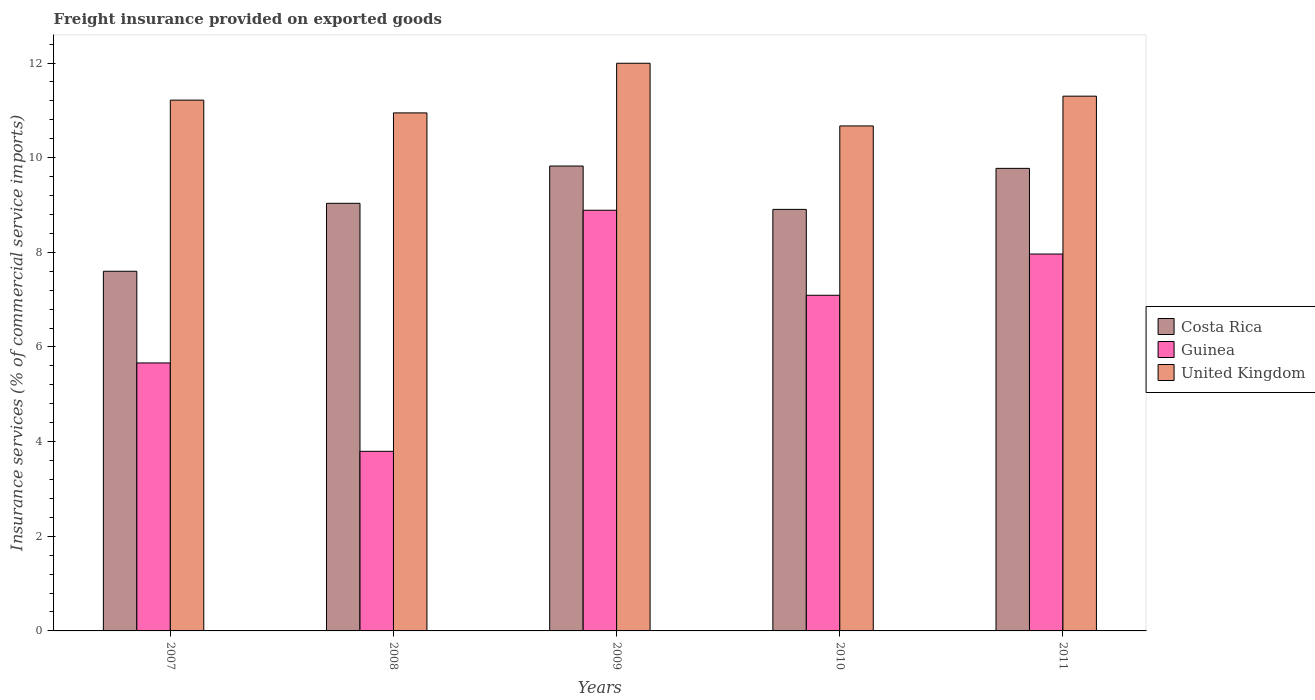How many different coloured bars are there?
Keep it short and to the point. 3. How many groups of bars are there?
Give a very brief answer. 5. In how many cases, is the number of bars for a given year not equal to the number of legend labels?
Your answer should be compact. 0. What is the freight insurance provided on exported goods in Guinea in 2009?
Keep it short and to the point. 8.89. Across all years, what is the maximum freight insurance provided on exported goods in Costa Rica?
Your response must be concise. 9.82. Across all years, what is the minimum freight insurance provided on exported goods in United Kingdom?
Your answer should be very brief. 10.67. In which year was the freight insurance provided on exported goods in Costa Rica maximum?
Offer a very short reply. 2009. In which year was the freight insurance provided on exported goods in United Kingdom minimum?
Offer a very short reply. 2010. What is the total freight insurance provided on exported goods in United Kingdom in the graph?
Provide a short and direct response. 56.13. What is the difference between the freight insurance provided on exported goods in Guinea in 2008 and that in 2010?
Provide a short and direct response. -3.3. What is the difference between the freight insurance provided on exported goods in Costa Rica in 2007 and the freight insurance provided on exported goods in Guinea in 2008?
Your response must be concise. 3.8. What is the average freight insurance provided on exported goods in Costa Rica per year?
Make the answer very short. 9.03. In the year 2008, what is the difference between the freight insurance provided on exported goods in Guinea and freight insurance provided on exported goods in United Kingdom?
Provide a short and direct response. -7.15. What is the ratio of the freight insurance provided on exported goods in Costa Rica in 2007 to that in 2008?
Keep it short and to the point. 0.84. What is the difference between the highest and the second highest freight insurance provided on exported goods in Guinea?
Provide a short and direct response. 0.92. What is the difference between the highest and the lowest freight insurance provided on exported goods in Guinea?
Your response must be concise. 5.09. In how many years, is the freight insurance provided on exported goods in United Kingdom greater than the average freight insurance provided on exported goods in United Kingdom taken over all years?
Make the answer very short. 2. What does the 1st bar from the left in 2008 represents?
Ensure brevity in your answer.  Costa Rica. What does the 2nd bar from the right in 2009 represents?
Keep it short and to the point. Guinea. Is it the case that in every year, the sum of the freight insurance provided on exported goods in Costa Rica and freight insurance provided on exported goods in United Kingdom is greater than the freight insurance provided on exported goods in Guinea?
Offer a very short reply. Yes. How many bars are there?
Offer a very short reply. 15. Are all the bars in the graph horizontal?
Make the answer very short. No. How many years are there in the graph?
Provide a short and direct response. 5. Does the graph contain grids?
Provide a succinct answer. No. Where does the legend appear in the graph?
Keep it short and to the point. Center right. How many legend labels are there?
Ensure brevity in your answer.  3. What is the title of the graph?
Give a very brief answer. Freight insurance provided on exported goods. What is the label or title of the Y-axis?
Your response must be concise. Insurance services (% of commercial service imports). What is the Insurance services (% of commercial service imports) in Costa Rica in 2007?
Provide a succinct answer. 7.6. What is the Insurance services (% of commercial service imports) of Guinea in 2007?
Provide a short and direct response. 5.66. What is the Insurance services (% of commercial service imports) in United Kingdom in 2007?
Ensure brevity in your answer.  11.22. What is the Insurance services (% of commercial service imports) in Costa Rica in 2008?
Keep it short and to the point. 9.04. What is the Insurance services (% of commercial service imports) in Guinea in 2008?
Offer a terse response. 3.8. What is the Insurance services (% of commercial service imports) in United Kingdom in 2008?
Ensure brevity in your answer.  10.95. What is the Insurance services (% of commercial service imports) of Costa Rica in 2009?
Keep it short and to the point. 9.82. What is the Insurance services (% of commercial service imports) in Guinea in 2009?
Provide a succinct answer. 8.89. What is the Insurance services (% of commercial service imports) in United Kingdom in 2009?
Keep it short and to the point. 12. What is the Insurance services (% of commercial service imports) of Costa Rica in 2010?
Keep it short and to the point. 8.91. What is the Insurance services (% of commercial service imports) in Guinea in 2010?
Provide a short and direct response. 7.09. What is the Insurance services (% of commercial service imports) in United Kingdom in 2010?
Keep it short and to the point. 10.67. What is the Insurance services (% of commercial service imports) in Costa Rica in 2011?
Your answer should be compact. 9.77. What is the Insurance services (% of commercial service imports) of Guinea in 2011?
Your answer should be compact. 7.96. What is the Insurance services (% of commercial service imports) of United Kingdom in 2011?
Make the answer very short. 11.3. Across all years, what is the maximum Insurance services (% of commercial service imports) in Costa Rica?
Your answer should be compact. 9.82. Across all years, what is the maximum Insurance services (% of commercial service imports) of Guinea?
Your answer should be compact. 8.89. Across all years, what is the maximum Insurance services (% of commercial service imports) in United Kingdom?
Offer a very short reply. 12. Across all years, what is the minimum Insurance services (% of commercial service imports) in Costa Rica?
Ensure brevity in your answer.  7.6. Across all years, what is the minimum Insurance services (% of commercial service imports) in Guinea?
Keep it short and to the point. 3.8. Across all years, what is the minimum Insurance services (% of commercial service imports) of United Kingdom?
Make the answer very short. 10.67. What is the total Insurance services (% of commercial service imports) of Costa Rica in the graph?
Keep it short and to the point. 45.14. What is the total Insurance services (% of commercial service imports) in Guinea in the graph?
Provide a succinct answer. 33.4. What is the total Insurance services (% of commercial service imports) of United Kingdom in the graph?
Your answer should be compact. 56.13. What is the difference between the Insurance services (% of commercial service imports) in Costa Rica in 2007 and that in 2008?
Your answer should be very brief. -1.44. What is the difference between the Insurance services (% of commercial service imports) of Guinea in 2007 and that in 2008?
Keep it short and to the point. 1.87. What is the difference between the Insurance services (% of commercial service imports) in United Kingdom in 2007 and that in 2008?
Offer a very short reply. 0.27. What is the difference between the Insurance services (% of commercial service imports) in Costa Rica in 2007 and that in 2009?
Make the answer very short. -2.22. What is the difference between the Insurance services (% of commercial service imports) of Guinea in 2007 and that in 2009?
Your answer should be compact. -3.23. What is the difference between the Insurance services (% of commercial service imports) of United Kingdom in 2007 and that in 2009?
Your response must be concise. -0.78. What is the difference between the Insurance services (% of commercial service imports) in Costa Rica in 2007 and that in 2010?
Give a very brief answer. -1.31. What is the difference between the Insurance services (% of commercial service imports) in Guinea in 2007 and that in 2010?
Make the answer very short. -1.43. What is the difference between the Insurance services (% of commercial service imports) of United Kingdom in 2007 and that in 2010?
Your answer should be compact. 0.55. What is the difference between the Insurance services (% of commercial service imports) of Costa Rica in 2007 and that in 2011?
Your answer should be very brief. -2.17. What is the difference between the Insurance services (% of commercial service imports) of Guinea in 2007 and that in 2011?
Your answer should be very brief. -2.3. What is the difference between the Insurance services (% of commercial service imports) of United Kingdom in 2007 and that in 2011?
Offer a very short reply. -0.08. What is the difference between the Insurance services (% of commercial service imports) in Costa Rica in 2008 and that in 2009?
Offer a terse response. -0.79. What is the difference between the Insurance services (% of commercial service imports) of Guinea in 2008 and that in 2009?
Make the answer very short. -5.09. What is the difference between the Insurance services (% of commercial service imports) in United Kingdom in 2008 and that in 2009?
Your answer should be very brief. -1.05. What is the difference between the Insurance services (% of commercial service imports) of Costa Rica in 2008 and that in 2010?
Your answer should be very brief. 0.13. What is the difference between the Insurance services (% of commercial service imports) of Guinea in 2008 and that in 2010?
Offer a terse response. -3.3. What is the difference between the Insurance services (% of commercial service imports) in United Kingdom in 2008 and that in 2010?
Your response must be concise. 0.28. What is the difference between the Insurance services (% of commercial service imports) of Costa Rica in 2008 and that in 2011?
Offer a terse response. -0.74. What is the difference between the Insurance services (% of commercial service imports) in Guinea in 2008 and that in 2011?
Your response must be concise. -4.17. What is the difference between the Insurance services (% of commercial service imports) in United Kingdom in 2008 and that in 2011?
Your answer should be very brief. -0.35. What is the difference between the Insurance services (% of commercial service imports) of Costa Rica in 2009 and that in 2010?
Provide a succinct answer. 0.92. What is the difference between the Insurance services (% of commercial service imports) in Guinea in 2009 and that in 2010?
Provide a succinct answer. 1.8. What is the difference between the Insurance services (% of commercial service imports) of United Kingdom in 2009 and that in 2010?
Make the answer very short. 1.32. What is the difference between the Insurance services (% of commercial service imports) of Costa Rica in 2009 and that in 2011?
Your response must be concise. 0.05. What is the difference between the Insurance services (% of commercial service imports) in Guinea in 2009 and that in 2011?
Give a very brief answer. 0.92. What is the difference between the Insurance services (% of commercial service imports) in United Kingdom in 2009 and that in 2011?
Make the answer very short. 0.7. What is the difference between the Insurance services (% of commercial service imports) in Costa Rica in 2010 and that in 2011?
Your answer should be compact. -0.87. What is the difference between the Insurance services (% of commercial service imports) in Guinea in 2010 and that in 2011?
Provide a succinct answer. -0.87. What is the difference between the Insurance services (% of commercial service imports) of United Kingdom in 2010 and that in 2011?
Provide a short and direct response. -0.63. What is the difference between the Insurance services (% of commercial service imports) in Costa Rica in 2007 and the Insurance services (% of commercial service imports) in Guinea in 2008?
Make the answer very short. 3.8. What is the difference between the Insurance services (% of commercial service imports) of Costa Rica in 2007 and the Insurance services (% of commercial service imports) of United Kingdom in 2008?
Your answer should be compact. -3.35. What is the difference between the Insurance services (% of commercial service imports) of Guinea in 2007 and the Insurance services (% of commercial service imports) of United Kingdom in 2008?
Your response must be concise. -5.28. What is the difference between the Insurance services (% of commercial service imports) in Costa Rica in 2007 and the Insurance services (% of commercial service imports) in Guinea in 2009?
Provide a succinct answer. -1.29. What is the difference between the Insurance services (% of commercial service imports) of Costa Rica in 2007 and the Insurance services (% of commercial service imports) of United Kingdom in 2009?
Offer a terse response. -4.4. What is the difference between the Insurance services (% of commercial service imports) in Guinea in 2007 and the Insurance services (% of commercial service imports) in United Kingdom in 2009?
Your answer should be very brief. -6.33. What is the difference between the Insurance services (% of commercial service imports) in Costa Rica in 2007 and the Insurance services (% of commercial service imports) in Guinea in 2010?
Provide a short and direct response. 0.51. What is the difference between the Insurance services (% of commercial service imports) in Costa Rica in 2007 and the Insurance services (% of commercial service imports) in United Kingdom in 2010?
Your answer should be very brief. -3.07. What is the difference between the Insurance services (% of commercial service imports) of Guinea in 2007 and the Insurance services (% of commercial service imports) of United Kingdom in 2010?
Your response must be concise. -5.01. What is the difference between the Insurance services (% of commercial service imports) in Costa Rica in 2007 and the Insurance services (% of commercial service imports) in Guinea in 2011?
Your answer should be very brief. -0.36. What is the difference between the Insurance services (% of commercial service imports) of Costa Rica in 2007 and the Insurance services (% of commercial service imports) of United Kingdom in 2011?
Offer a very short reply. -3.7. What is the difference between the Insurance services (% of commercial service imports) in Guinea in 2007 and the Insurance services (% of commercial service imports) in United Kingdom in 2011?
Your answer should be very brief. -5.64. What is the difference between the Insurance services (% of commercial service imports) of Costa Rica in 2008 and the Insurance services (% of commercial service imports) of Guinea in 2009?
Make the answer very short. 0.15. What is the difference between the Insurance services (% of commercial service imports) in Costa Rica in 2008 and the Insurance services (% of commercial service imports) in United Kingdom in 2009?
Ensure brevity in your answer.  -2.96. What is the difference between the Insurance services (% of commercial service imports) of Guinea in 2008 and the Insurance services (% of commercial service imports) of United Kingdom in 2009?
Offer a very short reply. -8.2. What is the difference between the Insurance services (% of commercial service imports) of Costa Rica in 2008 and the Insurance services (% of commercial service imports) of Guinea in 2010?
Your response must be concise. 1.94. What is the difference between the Insurance services (% of commercial service imports) of Costa Rica in 2008 and the Insurance services (% of commercial service imports) of United Kingdom in 2010?
Provide a succinct answer. -1.64. What is the difference between the Insurance services (% of commercial service imports) in Guinea in 2008 and the Insurance services (% of commercial service imports) in United Kingdom in 2010?
Your response must be concise. -6.88. What is the difference between the Insurance services (% of commercial service imports) of Costa Rica in 2008 and the Insurance services (% of commercial service imports) of Guinea in 2011?
Your answer should be very brief. 1.07. What is the difference between the Insurance services (% of commercial service imports) of Costa Rica in 2008 and the Insurance services (% of commercial service imports) of United Kingdom in 2011?
Your answer should be compact. -2.26. What is the difference between the Insurance services (% of commercial service imports) of Guinea in 2008 and the Insurance services (% of commercial service imports) of United Kingdom in 2011?
Your response must be concise. -7.5. What is the difference between the Insurance services (% of commercial service imports) of Costa Rica in 2009 and the Insurance services (% of commercial service imports) of Guinea in 2010?
Make the answer very short. 2.73. What is the difference between the Insurance services (% of commercial service imports) in Costa Rica in 2009 and the Insurance services (% of commercial service imports) in United Kingdom in 2010?
Keep it short and to the point. -0.85. What is the difference between the Insurance services (% of commercial service imports) in Guinea in 2009 and the Insurance services (% of commercial service imports) in United Kingdom in 2010?
Your response must be concise. -1.78. What is the difference between the Insurance services (% of commercial service imports) in Costa Rica in 2009 and the Insurance services (% of commercial service imports) in Guinea in 2011?
Offer a terse response. 1.86. What is the difference between the Insurance services (% of commercial service imports) in Costa Rica in 2009 and the Insurance services (% of commercial service imports) in United Kingdom in 2011?
Keep it short and to the point. -1.48. What is the difference between the Insurance services (% of commercial service imports) in Guinea in 2009 and the Insurance services (% of commercial service imports) in United Kingdom in 2011?
Offer a terse response. -2.41. What is the difference between the Insurance services (% of commercial service imports) of Costa Rica in 2010 and the Insurance services (% of commercial service imports) of Guinea in 2011?
Ensure brevity in your answer.  0.94. What is the difference between the Insurance services (% of commercial service imports) of Costa Rica in 2010 and the Insurance services (% of commercial service imports) of United Kingdom in 2011?
Make the answer very short. -2.39. What is the difference between the Insurance services (% of commercial service imports) of Guinea in 2010 and the Insurance services (% of commercial service imports) of United Kingdom in 2011?
Your answer should be very brief. -4.21. What is the average Insurance services (% of commercial service imports) of Costa Rica per year?
Offer a terse response. 9.03. What is the average Insurance services (% of commercial service imports) in Guinea per year?
Ensure brevity in your answer.  6.68. What is the average Insurance services (% of commercial service imports) of United Kingdom per year?
Give a very brief answer. 11.23. In the year 2007, what is the difference between the Insurance services (% of commercial service imports) of Costa Rica and Insurance services (% of commercial service imports) of Guinea?
Ensure brevity in your answer.  1.94. In the year 2007, what is the difference between the Insurance services (% of commercial service imports) in Costa Rica and Insurance services (% of commercial service imports) in United Kingdom?
Offer a very short reply. -3.62. In the year 2007, what is the difference between the Insurance services (% of commercial service imports) of Guinea and Insurance services (% of commercial service imports) of United Kingdom?
Ensure brevity in your answer.  -5.55. In the year 2008, what is the difference between the Insurance services (% of commercial service imports) of Costa Rica and Insurance services (% of commercial service imports) of Guinea?
Offer a terse response. 5.24. In the year 2008, what is the difference between the Insurance services (% of commercial service imports) in Costa Rica and Insurance services (% of commercial service imports) in United Kingdom?
Provide a succinct answer. -1.91. In the year 2008, what is the difference between the Insurance services (% of commercial service imports) in Guinea and Insurance services (% of commercial service imports) in United Kingdom?
Keep it short and to the point. -7.15. In the year 2009, what is the difference between the Insurance services (% of commercial service imports) of Costa Rica and Insurance services (% of commercial service imports) of Guinea?
Your answer should be compact. 0.93. In the year 2009, what is the difference between the Insurance services (% of commercial service imports) in Costa Rica and Insurance services (% of commercial service imports) in United Kingdom?
Ensure brevity in your answer.  -2.17. In the year 2009, what is the difference between the Insurance services (% of commercial service imports) of Guinea and Insurance services (% of commercial service imports) of United Kingdom?
Your response must be concise. -3.11. In the year 2010, what is the difference between the Insurance services (% of commercial service imports) in Costa Rica and Insurance services (% of commercial service imports) in Guinea?
Give a very brief answer. 1.81. In the year 2010, what is the difference between the Insurance services (% of commercial service imports) of Costa Rica and Insurance services (% of commercial service imports) of United Kingdom?
Give a very brief answer. -1.76. In the year 2010, what is the difference between the Insurance services (% of commercial service imports) of Guinea and Insurance services (% of commercial service imports) of United Kingdom?
Provide a short and direct response. -3.58. In the year 2011, what is the difference between the Insurance services (% of commercial service imports) in Costa Rica and Insurance services (% of commercial service imports) in Guinea?
Keep it short and to the point. 1.81. In the year 2011, what is the difference between the Insurance services (% of commercial service imports) in Costa Rica and Insurance services (% of commercial service imports) in United Kingdom?
Make the answer very short. -1.53. In the year 2011, what is the difference between the Insurance services (% of commercial service imports) of Guinea and Insurance services (% of commercial service imports) of United Kingdom?
Provide a short and direct response. -3.34. What is the ratio of the Insurance services (% of commercial service imports) in Costa Rica in 2007 to that in 2008?
Your response must be concise. 0.84. What is the ratio of the Insurance services (% of commercial service imports) in Guinea in 2007 to that in 2008?
Give a very brief answer. 1.49. What is the ratio of the Insurance services (% of commercial service imports) of United Kingdom in 2007 to that in 2008?
Give a very brief answer. 1.02. What is the ratio of the Insurance services (% of commercial service imports) in Costa Rica in 2007 to that in 2009?
Provide a short and direct response. 0.77. What is the ratio of the Insurance services (% of commercial service imports) of Guinea in 2007 to that in 2009?
Offer a terse response. 0.64. What is the ratio of the Insurance services (% of commercial service imports) of United Kingdom in 2007 to that in 2009?
Make the answer very short. 0.94. What is the ratio of the Insurance services (% of commercial service imports) of Costa Rica in 2007 to that in 2010?
Your response must be concise. 0.85. What is the ratio of the Insurance services (% of commercial service imports) in Guinea in 2007 to that in 2010?
Your answer should be very brief. 0.8. What is the ratio of the Insurance services (% of commercial service imports) in United Kingdom in 2007 to that in 2010?
Offer a terse response. 1.05. What is the ratio of the Insurance services (% of commercial service imports) in Costa Rica in 2007 to that in 2011?
Keep it short and to the point. 0.78. What is the ratio of the Insurance services (% of commercial service imports) of Guinea in 2007 to that in 2011?
Offer a terse response. 0.71. What is the ratio of the Insurance services (% of commercial service imports) in Costa Rica in 2008 to that in 2009?
Offer a very short reply. 0.92. What is the ratio of the Insurance services (% of commercial service imports) in Guinea in 2008 to that in 2009?
Your response must be concise. 0.43. What is the ratio of the Insurance services (% of commercial service imports) of United Kingdom in 2008 to that in 2009?
Keep it short and to the point. 0.91. What is the ratio of the Insurance services (% of commercial service imports) of Costa Rica in 2008 to that in 2010?
Ensure brevity in your answer.  1.01. What is the ratio of the Insurance services (% of commercial service imports) of Guinea in 2008 to that in 2010?
Your answer should be compact. 0.54. What is the ratio of the Insurance services (% of commercial service imports) of United Kingdom in 2008 to that in 2010?
Ensure brevity in your answer.  1.03. What is the ratio of the Insurance services (% of commercial service imports) of Costa Rica in 2008 to that in 2011?
Keep it short and to the point. 0.92. What is the ratio of the Insurance services (% of commercial service imports) in Guinea in 2008 to that in 2011?
Provide a succinct answer. 0.48. What is the ratio of the Insurance services (% of commercial service imports) of United Kingdom in 2008 to that in 2011?
Provide a succinct answer. 0.97. What is the ratio of the Insurance services (% of commercial service imports) in Costa Rica in 2009 to that in 2010?
Make the answer very short. 1.1. What is the ratio of the Insurance services (% of commercial service imports) in Guinea in 2009 to that in 2010?
Ensure brevity in your answer.  1.25. What is the ratio of the Insurance services (% of commercial service imports) in United Kingdom in 2009 to that in 2010?
Keep it short and to the point. 1.12. What is the ratio of the Insurance services (% of commercial service imports) of Costa Rica in 2009 to that in 2011?
Ensure brevity in your answer.  1.01. What is the ratio of the Insurance services (% of commercial service imports) of Guinea in 2009 to that in 2011?
Ensure brevity in your answer.  1.12. What is the ratio of the Insurance services (% of commercial service imports) in United Kingdom in 2009 to that in 2011?
Ensure brevity in your answer.  1.06. What is the ratio of the Insurance services (% of commercial service imports) in Costa Rica in 2010 to that in 2011?
Ensure brevity in your answer.  0.91. What is the ratio of the Insurance services (% of commercial service imports) of Guinea in 2010 to that in 2011?
Provide a short and direct response. 0.89. What is the ratio of the Insurance services (% of commercial service imports) in United Kingdom in 2010 to that in 2011?
Offer a very short reply. 0.94. What is the difference between the highest and the second highest Insurance services (% of commercial service imports) in Costa Rica?
Ensure brevity in your answer.  0.05. What is the difference between the highest and the second highest Insurance services (% of commercial service imports) in Guinea?
Your response must be concise. 0.92. What is the difference between the highest and the second highest Insurance services (% of commercial service imports) in United Kingdom?
Make the answer very short. 0.7. What is the difference between the highest and the lowest Insurance services (% of commercial service imports) in Costa Rica?
Your response must be concise. 2.22. What is the difference between the highest and the lowest Insurance services (% of commercial service imports) in Guinea?
Your response must be concise. 5.09. What is the difference between the highest and the lowest Insurance services (% of commercial service imports) of United Kingdom?
Your response must be concise. 1.32. 